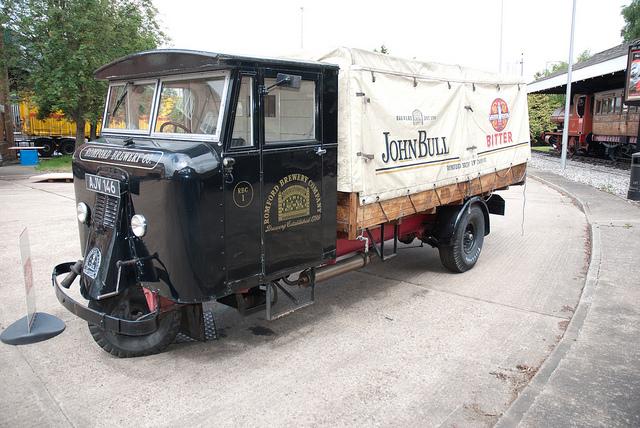What name is on the truck?
Quick response, please. John bull. What color is this truck?
Give a very brief answer. Black. What is the round metal thing in the street called?
Keep it brief. Sign. Is this a semi truck?
Concise answer only. No. What is shown in the reflection in the reflection on the window of the truck?
Answer briefly. Building. 